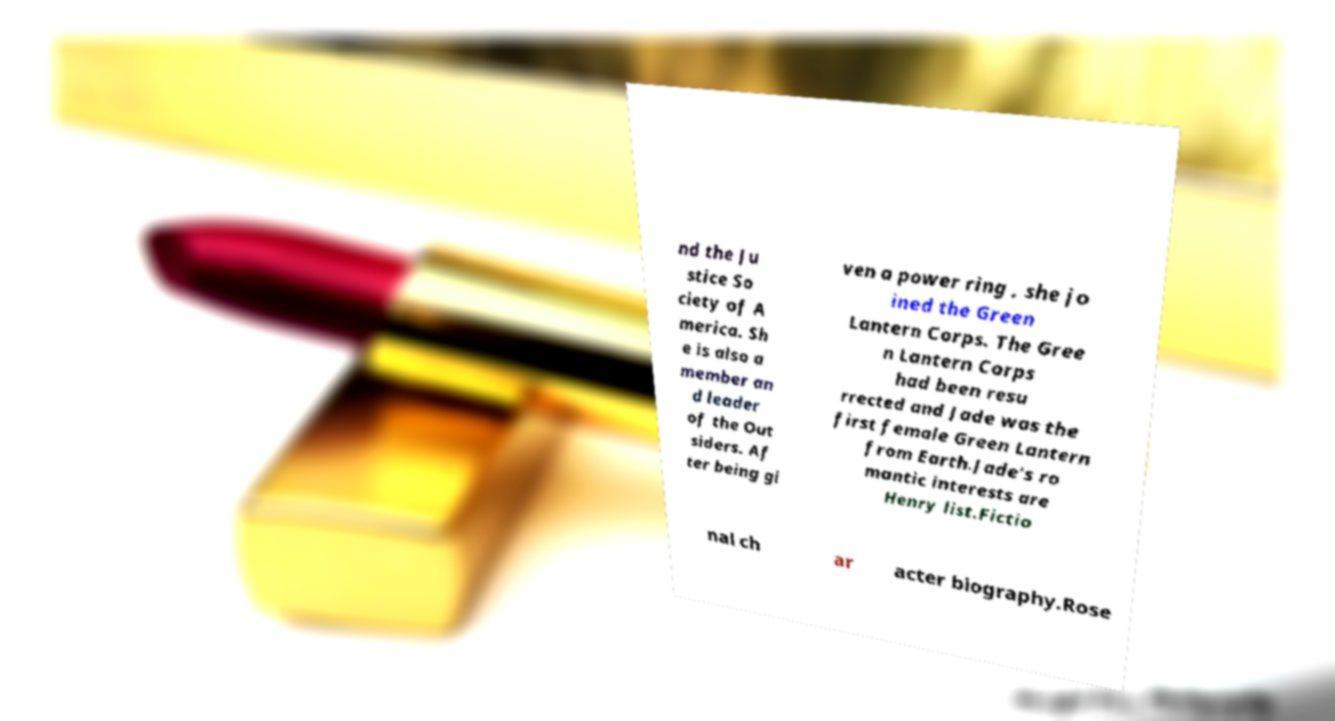What messages or text are displayed in this image? I need them in a readable, typed format. nd the Ju stice So ciety of A merica. Sh e is also a member an d leader of the Out siders. Af ter being gi ven a power ring , she jo ined the Green Lantern Corps. The Gree n Lantern Corps had been resu rrected and Jade was the first female Green Lantern from Earth.Jade's ro mantic interests are Henry list.Fictio nal ch ar acter biography.Rose 